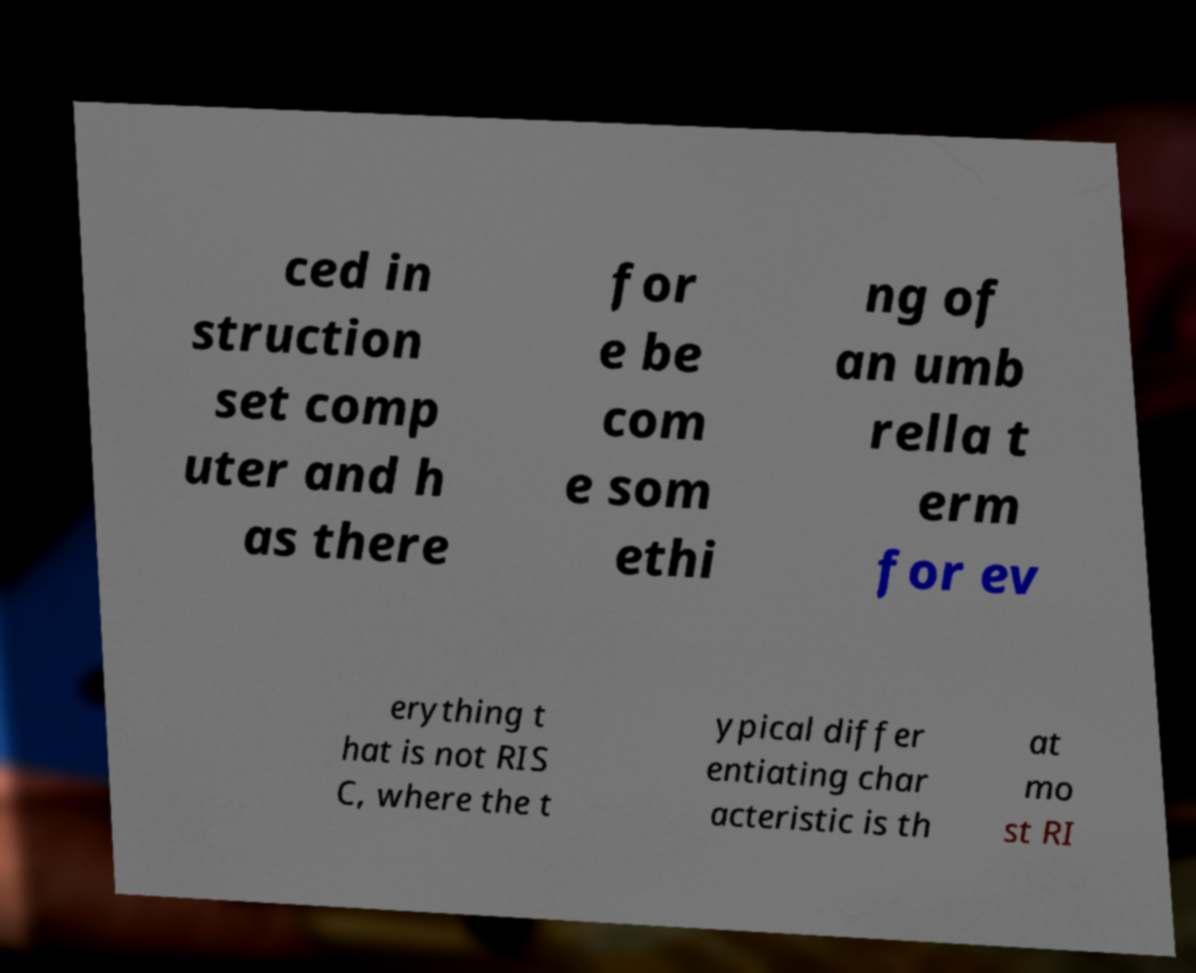I need the written content from this picture converted into text. Can you do that? ced in struction set comp uter and h as there for e be com e som ethi ng of an umb rella t erm for ev erything t hat is not RIS C, where the t ypical differ entiating char acteristic is th at mo st RI 